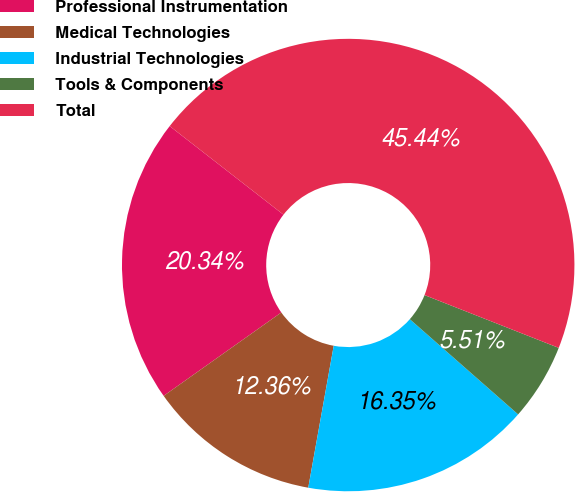<chart> <loc_0><loc_0><loc_500><loc_500><pie_chart><fcel>Professional Instrumentation<fcel>Medical Technologies<fcel>Industrial Technologies<fcel>Tools & Components<fcel>Total<nl><fcel>20.34%<fcel>12.36%<fcel>16.35%<fcel>5.51%<fcel>45.44%<nl></chart> 